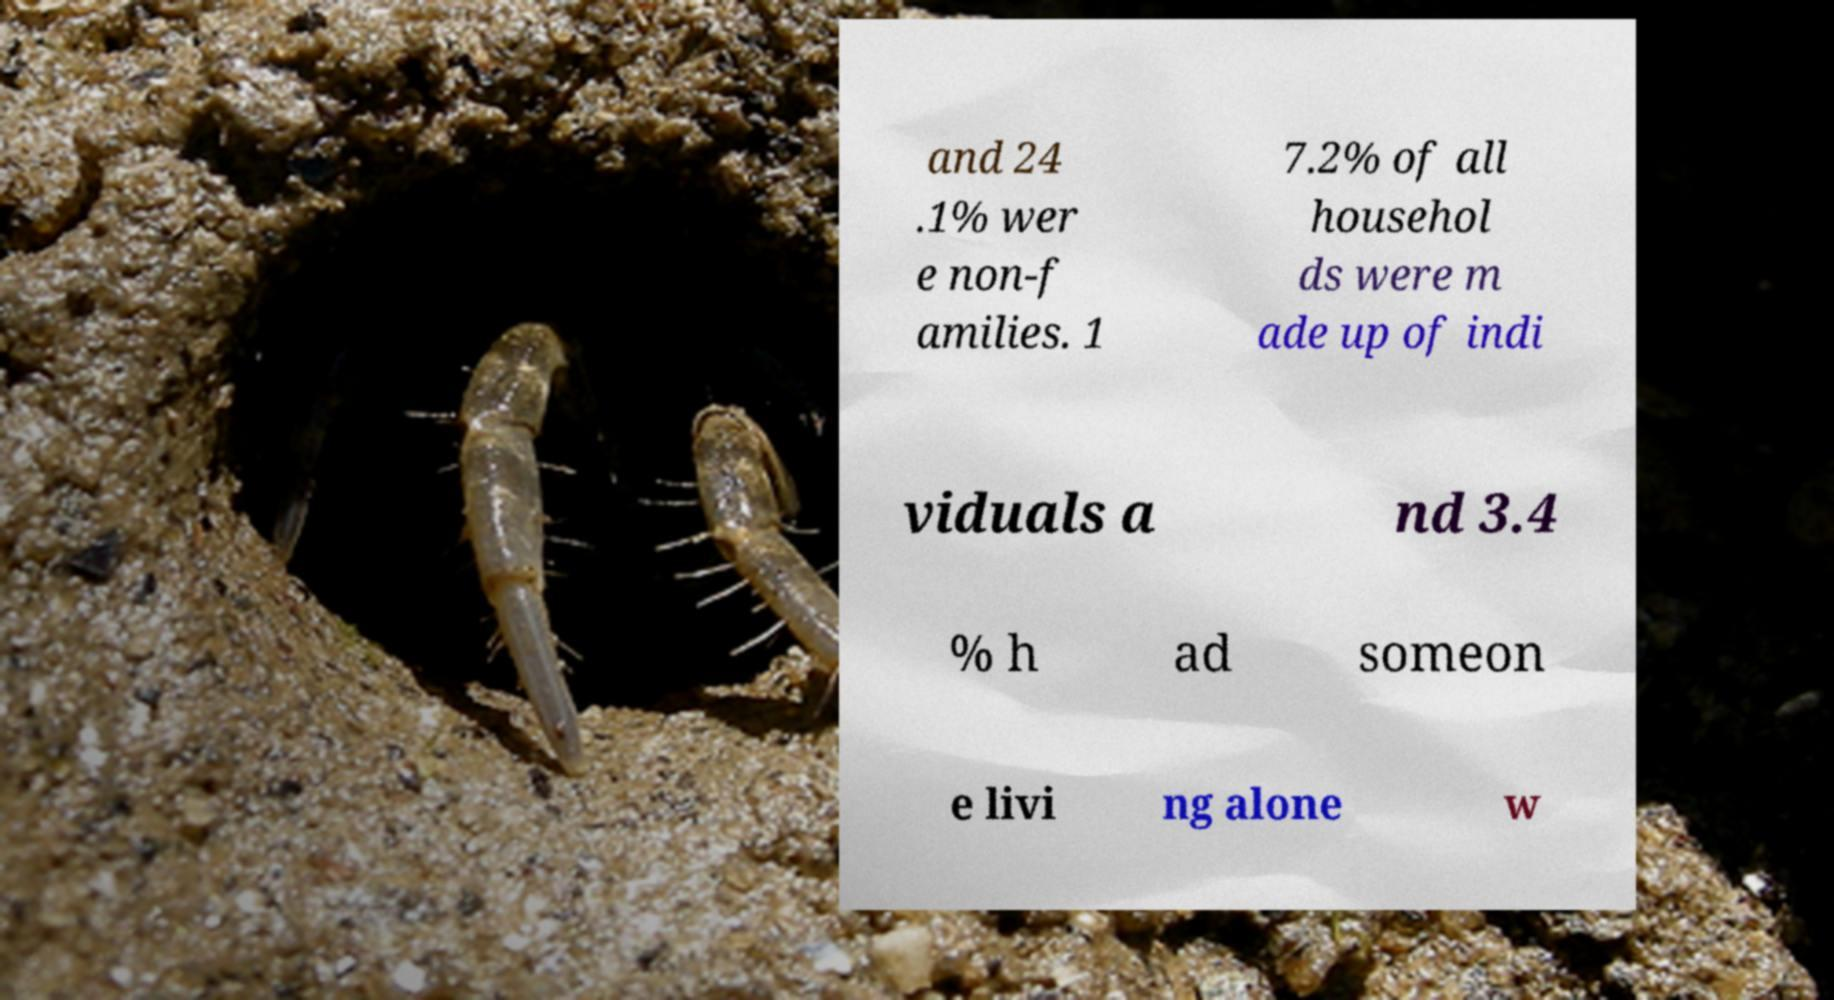Could you extract and type out the text from this image? and 24 .1% wer e non-f amilies. 1 7.2% of all househol ds were m ade up of indi viduals a nd 3.4 % h ad someon e livi ng alone w 